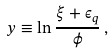Convert formula to latex. <formula><loc_0><loc_0><loc_500><loc_500>y \equiv \ln \frac { \xi + \epsilon _ { q } } { \phi } \, ,</formula> 